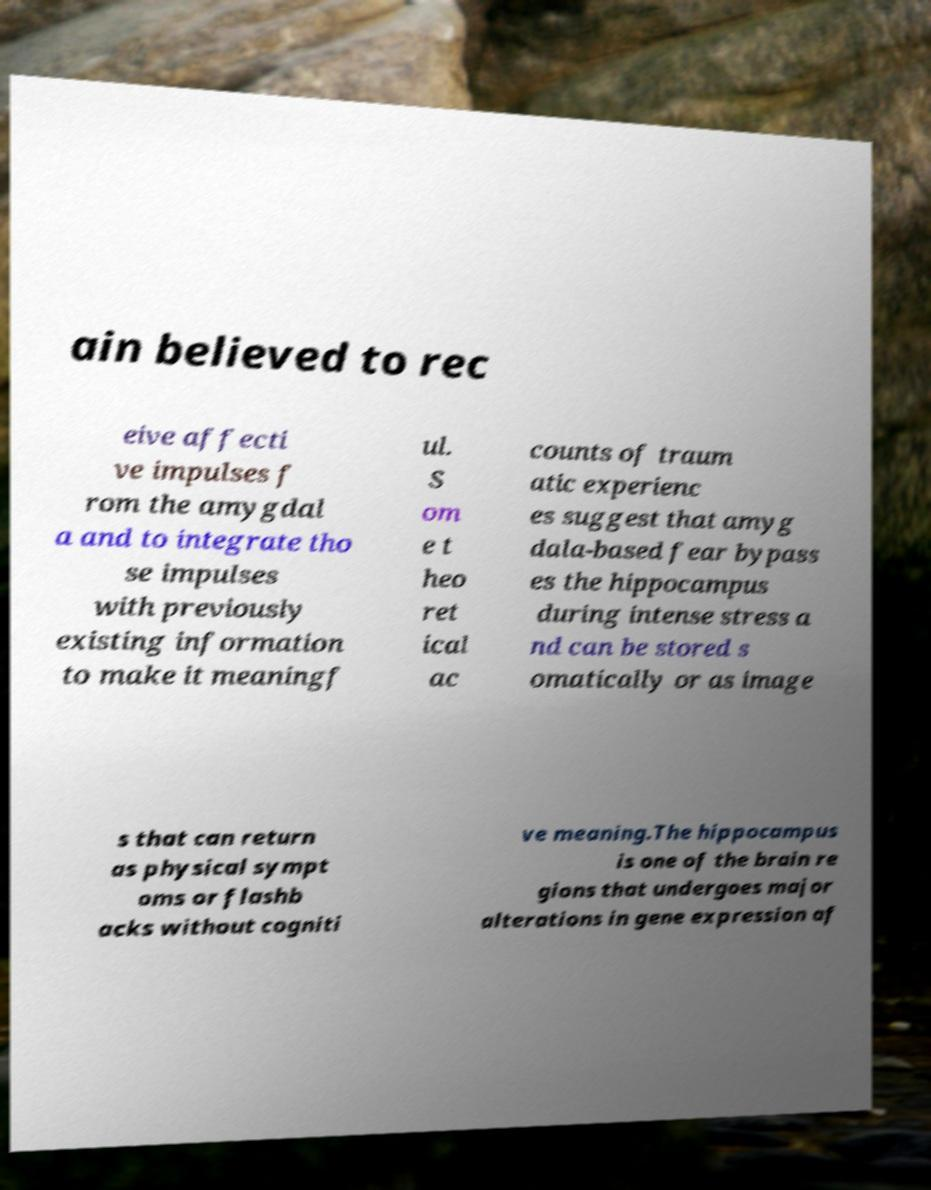What messages or text are displayed in this image? I need them in a readable, typed format. ain believed to rec eive affecti ve impulses f rom the amygdal a and to integrate tho se impulses with previously existing information to make it meaningf ul. S om e t heo ret ical ac counts of traum atic experienc es suggest that amyg dala-based fear bypass es the hippocampus during intense stress a nd can be stored s omatically or as image s that can return as physical sympt oms or flashb acks without cogniti ve meaning.The hippocampus is one of the brain re gions that undergoes major alterations in gene expression af 